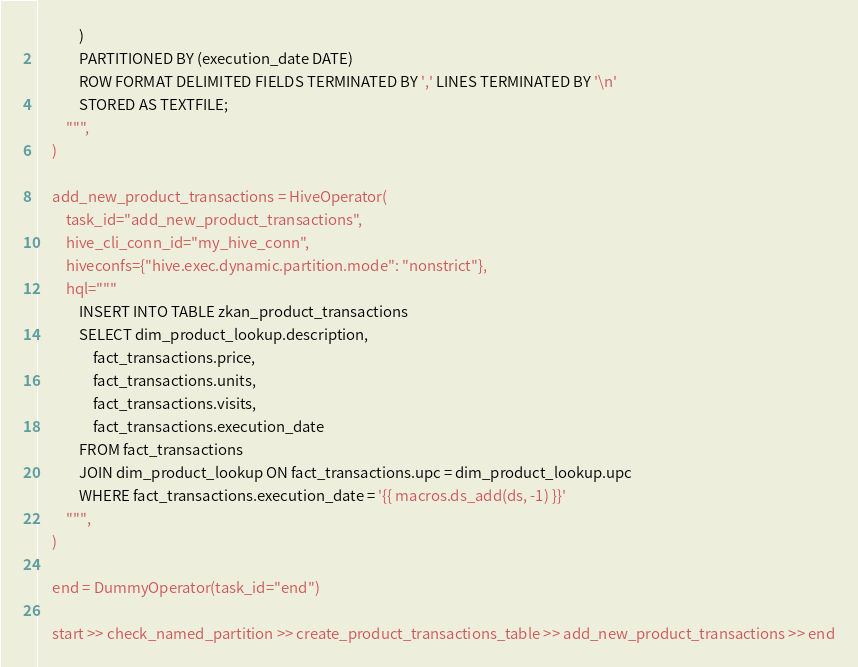<code> <loc_0><loc_0><loc_500><loc_500><_Python_>            )
            PARTITIONED BY (execution_date DATE)
            ROW FORMAT DELIMITED FIELDS TERMINATED BY ',' LINES TERMINATED BY '\n'
            STORED AS TEXTFILE;
        """,
    )

    add_new_product_transactions = HiveOperator(
        task_id="add_new_product_transactions",
        hive_cli_conn_id="my_hive_conn",
        hiveconfs={"hive.exec.dynamic.partition.mode": "nonstrict"},
        hql="""
            INSERT INTO TABLE zkan_product_transactions
            SELECT dim_product_lookup.description,
                fact_transactions.price,
                fact_transactions.units,
                fact_transactions.visits,
                fact_transactions.execution_date
            FROM fact_transactions
            JOIN dim_product_lookup ON fact_transactions.upc = dim_product_lookup.upc
            WHERE fact_transactions.execution_date = '{{ macros.ds_add(ds, -1) }}'
        """,
    )

    end = DummyOperator(task_id="end")

    start >> check_named_partition >> create_product_transactions_table >> add_new_product_transactions >> end</code> 